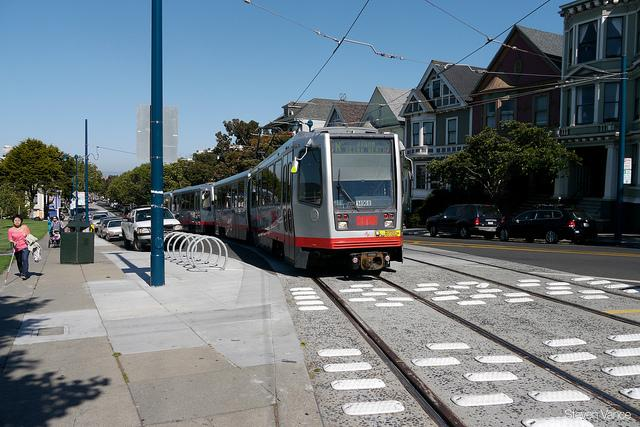The person nearest has what handicap?

Choices:
A) lameness
B) hearing
C) heart defect
D) blindness blindness 